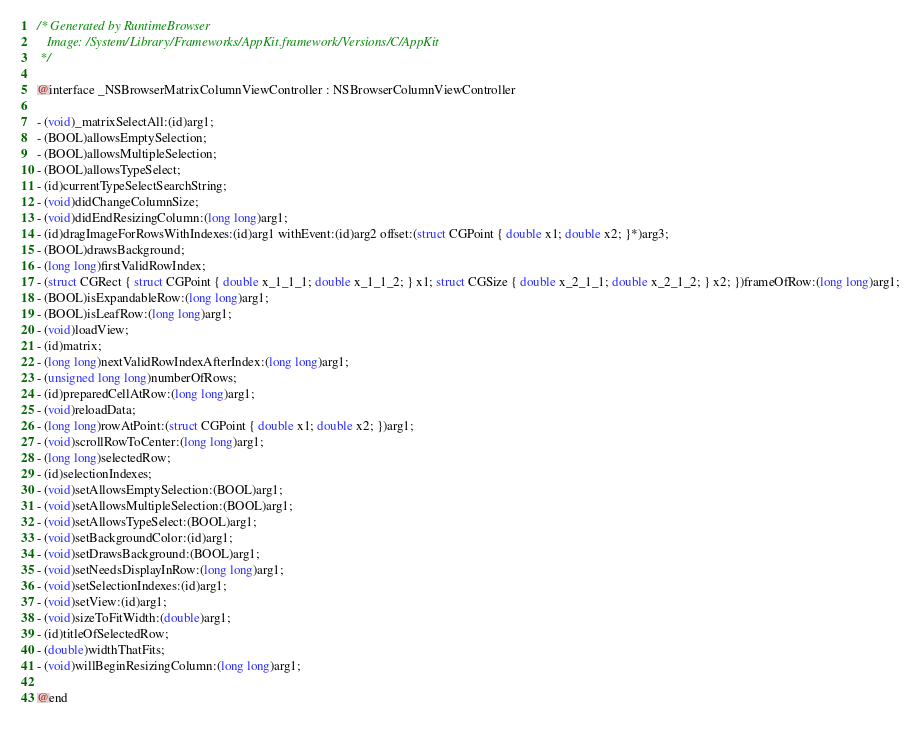Convert code to text. <code><loc_0><loc_0><loc_500><loc_500><_C_>/* Generated by RuntimeBrowser
   Image: /System/Library/Frameworks/AppKit.framework/Versions/C/AppKit
 */

@interface _NSBrowserMatrixColumnViewController : NSBrowserColumnViewController

- (void)_matrixSelectAll:(id)arg1;
- (BOOL)allowsEmptySelection;
- (BOOL)allowsMultipleSelection;
- (BOOL)allowsTypeSelect;
- (id)currentTypeSelectSearchString;
- (void)didChangeColumnSize;
- (void)didEndResizingColumn:(long long)arg1;
- (id)dragImageForRowsWithIndexes:(id)arg1 withEvent:(id)arg2 offset:(struct CGPoint { double x1; double x2; }*)arg3;
- (BOOL)drawsBackground;
- (long long)firstValidRowIndex;
- (struct CGRect { struct CGPoint { double x_1_1_1; double x_1_1_2; } x1; struct CGSize { double x_2_1_1; double x_2_1_2; } x2; })frameOfRow:(long long)arg1;
- (BOOL)isExpandableRow:(long long)arg1;
- (BOOL)isLeafRow:(long long)arg1;
- (void)loadView;
- (id)matrix;
- (long long)nextValidRowIndexAfterIndex:(long long)arg1;
- (unsigned long long)numberOfRows;
- (id)preparedCellAtRow:(long long)arg1;
- (void)reloadData;
- (long long)rowAtPoint:(struct CGPoint { double x1; double x2; })arg1;
- (void)scrollRowToCenter:(long long)arg1;
- (long long)selectedRow;
- (id)selectionIndexes;
- (void)setAllowsEmptySelection:(BOOL)arg1;
- (void)setAllowsMultipleSelection:(BOOL)arg1;
- (void)setAllowsTypeSelect:(BOOL)arg1;
- (void)setBackgroundColor:(id)arg1;
- (void)setDrawsBackground:(BOOL)arg1;
- (void)setNeedsDisplayInRow:(long long)arg1;
- (void)setSelectionIndexes:(id)arg1;
- (void)setView:(id)arg1;
- (void)sizeToFitWidth:(double)arg1;
- (id)titleOfSelectedRow;
- (double)widthThatFits;
- (void)willBeginResizingColumn:(long long)arg1;

@end
</code> 